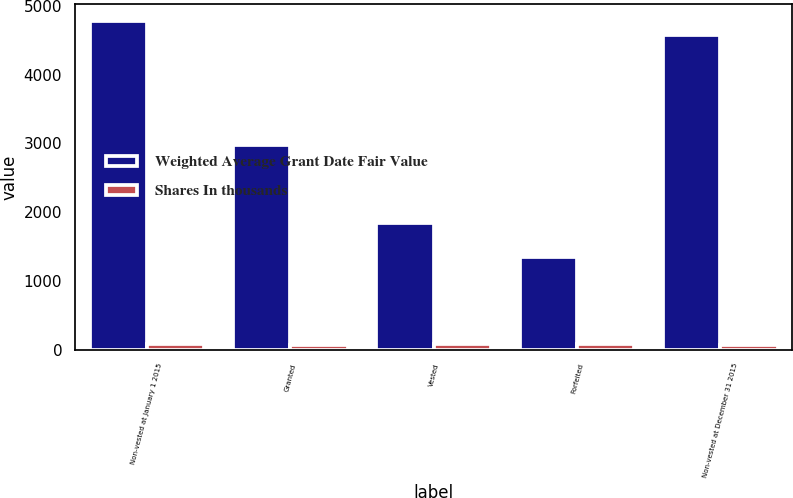<chart> <loc_0><loc_0><loc_500><loc_500><stacked_bar_chart><ecel><fcel>Non-vested at January 1 2015<fcel>Granted<fcel>Vested<fcel>Forfeited<fcel>Non-vested at December 31 2015<nl><fcel>Weighted Average Grant Date Fair Value<fcel>4784<fcel>2976<fcel>1839<fcel>1351<fcel>4570<nl><fcel>Shares In thousands<fcel>81.96<fcel>61.65<fcel>81.14<fcel>78.26<fcel>70.12<nl></chart> 